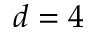<formula> <loc_0><loc_0><loc_500><loc_500>d = 4</formula> 